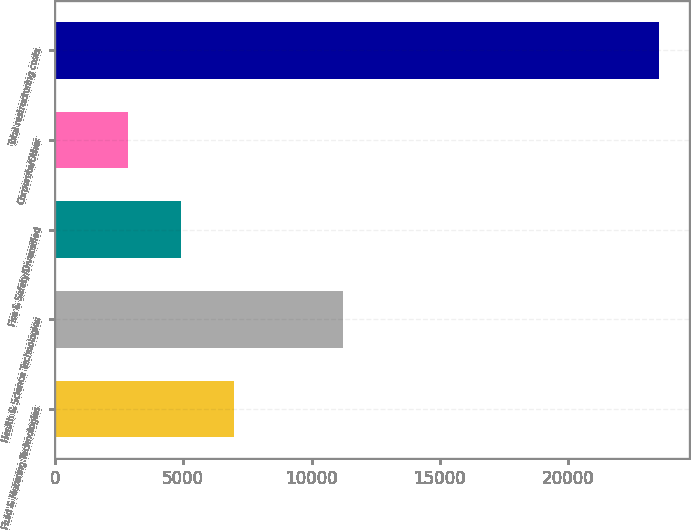Convert chart to OTSL. <chart><loc_0><loc_0><loc_500><loc_500><bar_chart><fcel>Fluid & Metering Technologies<fcel>Health & Science Technologies<fcel>Fire & Safety/Diversified<fcel>Corporate/Other<fcel>Total restructuring costs<nl><fcel>6979<fcel>11223<fcel>4911.5<fcel>2844<fcel>23519<nl></chart> 